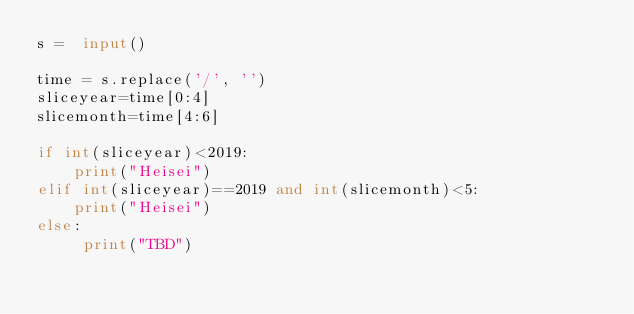Convert code to text. <code><loc_0><loc_0><loc_500><loc_500><_Python_>s =  input()

time = s.replace('/', '')
sliceyear=time[0:4]
slicemonth=time[4:6]

if int(sliceyear)<2019:
    print("Heisei")
elif int(sliceyear)==2019 and int(slicemonth)<5:
    print("Heisei")
else:
     print("TBD")</code> 